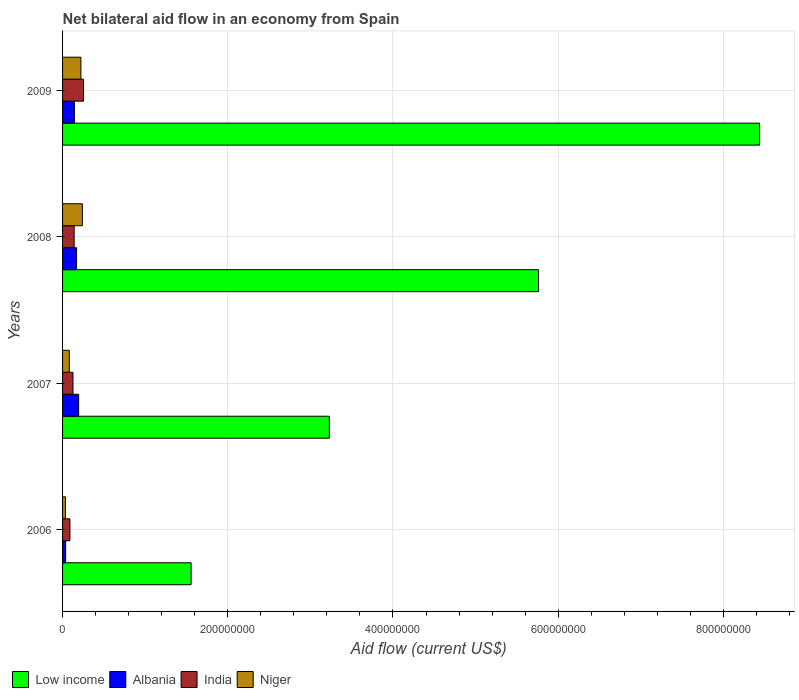How many different coloured bars are there?
Your response must be concise. 4. How many groups of bars are there?
Offer a terse response. 4. Are the number of bars on each tick of the Y-axis equal?
Give a very brief answer. Yes. How many bars are there on the 4th tick from the top?
Provide a succinct answer. 4. How many bars are there on the 4th tick from the bottom?
Offer a very short reply. 4. What is the net bilateral aid flow in Low income in 2009?
Keep it short and to the point. 8.44e+08. Across all years, what is the maximum net bilateral aid flow in Low income?
Keep it short and to the point. 8.44e+08. Across all years, what is the minimum net bilateral aid flow in Low income?
Make the answer very short. 1.56e+08. What is the total net bilateral aid flow in Low income in the graph?
Give a very brief answer. 1.90e+09. What is the difference between the net bilateral aid flow in Niger in 2007 and that in 2008?
Give a very brief answer. -1.58e+07. What is the difference between the net bilateral aid flow in Niger in 2006 and the net bilateral aid flow in Albania in 2007?
Provide a short and direct response. -1.60e+07. What is the average net bilateral aid flow in Low income per year?
Offer a very short reply. 4.75e+08. In the year 2007, what is the difference between the net bilateral aid flow in India and net bilateral aid flow in Niger?
Ensure brevity in your answer.  4.43e+06. In how many years, is the net bilateral aid flow in India greater than 600000000 US$?
Make the answer very short. 0. What is the ratio of the net bilateral aid flow in India in 2008 to that in 2009?
Provide a short and direct response. 0.55. Is the net bilateral aid flow in Low income in 2006 less than that in 2009?
Your response must be concise. Yes. What is the difference between the highest and the second highest net bilateral aid flow in India?
Your answer should be compact. 1.13e+07. What is the difference between the highest and the lowest net bilateral aid flow in Low income?
Provide a succinct answer. 6.88e+08. In how many years, is the net bilateral aid flow in Albania greater than the average net bilateral aid flow in Albania taken over all years?
Provide a succinct answer. 3. Is the sum of the net bilateral aid flow in Low income in 2006 and 2007 greater than the maximum net bilateral aid flow in India across all years?
Your answer should be very brief. Yes. Is it the case that in every year, the sum of the net bilateral aid flow in Low income and net bilateral aid flow in India is greater than the sum of net bilateral aid flow in Niger and net bilateral aid flow in Albania?
Provide a short and direct response. Yes. What does the 1st bar from the top in 2007 represents?
Provide a succinct answer. Niger. What does the 2nd bar from the bottom in 2006 represents?
Provide a short and direct response. Albania. Is it the case that in every year, the sum of the net bilateral aid flow in India and net bilateral aid flow in Niger is greater than the net bilateral aid flow in Low income?
Provide a short and direct response. No. How many bars are there?
Offer a very short reply. 16. How many years are there in the graph?
Your answer should be compact. 4. Are the values on the major ticks of X-axis written in scientific E-notation?
Provide a succinct answer. No. Does the graph contain any zero values?
Offer a very short reply. No. Does the graph contain grids?
Make the answer very short. Yes. Where does the legend appear in the graph?
Keep it short and to the point. Bottom left. How many legend labels are there?
Your answer should be compact. 4. How are the legend labels stacked?
Provide a succinct answer. Horizontal. What is the title of the graph?
Your answer should be compact. Net bilateral aid flow in an economy from Spain. Does "Sierra Leone" appear as one of the legend labels in the graph?
Give a very brief answer. No. What is the label or title of the Y-axis?
Your response must be concise. Years. What is the Aid flow (current US$) of Low income in 2006?
Provide a short and direct response. 1.56e+08. What is the Aid flow (current US$) of Albania in 2006?
Keep it short and to the point. 3.71e+06. What is the Aid flow (current US$) in India in 2006?
Ensure brevity in your answer.  8.91e+06. What is the Aid flow (current US$) of Niger in 2006?
Keep it short and to the point. 3.49e+06. What is the Aid flow (current US$) of Low income in 2007?
Provide a short and direct response. 3.23e+08. What is the Aid flow (current US$) in Albania in 2007?
Provide a short and direct response. 1.95e+07. What is the Aid flow (current US$) of India in 2007?
Provide a succinct answer. 1.26e+07. What is the Aid flow (current US$) of Niger in 2007?
Offer a very short reply. 8.19e+06. What is the Aid flow (current US$) of Low income in 2008?
Keep it short and to the point. 5.76e+08. What is the Aid flow (current US$) in Albania in 2008?
Your answer should be very brief. 1.69e+07. What is the Aid flow (current US$) in India in 2008?
Your answer should be very brief. 1.40e+07. What is the Aid flow (current US$) in Niger in 2008?
Provide a succinct answer. 2.40e+07. What is the Aid flow (current US$) in Low income in 2009?
Give a very brief answer. 8.44e+08. What is the Aid flow (current US$) of Albania in 2009?
Ensure brevity in your answer.  1.43e+07. What is the Aid flow (current US$) in India in 2009?
Keep it short and to the point. 2.53e+07. What is the Aid flow (current US$) of Niger in 2009?
Provide a short and direct response. 2.22e+07. Across all years, what is the maximum Aid flow (current US$) of Low income?
Provide a succinct answer. 8.44e+08. Across all years, what is the maximum Aid flow (current US$) of Albania?
Ensure brevity in your answer.  1.95e+07. Across all years, what is the maximum Aid flow (current US$) in India?
Provide a short and direct response. 2.53e+07. Across all years, what is the maximum Aid flow (current US$) of Niger?
Make the answer very short. 2.40e+07. Across all years, what is the minimum Aid flow (current US$) of Low income?
Provide a short and direct response. 1.56e+08. Across all years, what is the minimum Aid flow (current US$) in Albania?
Your response must be concise. 3.71e+06. Across all years, what is the minimum Aid flow (current US$) in India?
Keep it short and to the point. 8.91e+06. Across all years, what is the minimum Aid flow (current US$) in Niger?
Give a very brief answer. 3.49e+06. What is the total Aid flow (current US$) in Low income in the graph?
Your response must be concise. 1.90e+09. What is the total Aid flow (current US$) of Albania in the graph?
Make the answer very short. 5.44e+07. What is the total Aid flow (current US$) of India in the graph?
Provide a succinct answer. 6.09e+07. What is the total Aid flow (current US$) in Niger in the graph?
Make the answer very short. 5.79e+07. What is the difference between the Aid flow (current US$) in Low income in 2006 and that in 2007?
Provide a succinct answer. -1.67e+08. What is the difference between the Aid flow (current US$) in Albania in 2006 and that in 2007?
Your answer should be compact. -1.58e+07. What is the difference between the Aid flow (current US$) in India in 2006 and that in 2007?
Offer a very short reply. -3.71e+06. What is the difference between the Aid flow (current US$) in Niger in 2006 and that in 2007?
Your answer should be very brief. -4.70e+06. What is the difference between the Aid flow (current US$) of Low income in 2006 and that in 2008?
Your answer should be very brief. -4.21e+08. What is the difference between the Aid flow (current US$) in Albania in 2006 and that in 2008?
Provide a short and direct response. -1.32e+07. What is the difference between the Aid flow (current US$) of India in 2006 and that in 2008?
Offer a very short reply. -5.13e+06. What is the difference between the Aid flow (current US$) in Niger in 2006 and that in 2008?
Offer a terse response. -2.05e+07. What is the difference between the Aid flow (current US$) in Low income in 2006 and that in 2009?
Give a very brief answer. -6.88e+08. What is the difference between the Aid flow (current US$) in Albania in 2006 and that in 2009?
Make the answer very short. -1.06e+07. What is the difference between the Aid flow (current US$) in India in 2006 and that in 2009?
Provide a succinct answer. -1.64e+07. What is the difference between the Aid flow (current US$) of Niger in 2006 and that in 2009?
Your answer should be very brief. -1.87e+07. What is the difference between the Aid flow (current US$) of Low income in 2007 and that in 2008?
Your response must be concise. -2.53e+08. What is the difference between the Aid flow (current US$) of Albania in 2007 and that in 2008?
Provide a short and direct response. 2.54e+06. What is the difference between the Aid flow (current US$) in India in 2007 and that in 2008?
Ensure brevity in your answer.  -1.42e+06. What is the difference between the Aid flow (current US$) of Niger in 2007 and that in 2008?
Provide a succinct answer. -1.58e+07. What is the difference between the Aid flow (current US$) of Low income in 2007 and that in 2009?
Your response must be concise. -5.21e+08. What is the difference between the Aid flow (current US$) in Albania in 2007 and that in 2009?
Your answer should be compact. 5.13e+06. What is the difference between the Aid flow (current US$) in India in 2007 and that in 2009?
Provide a succinct answer. -1.27e+07. What is the difference between the Aid flow (current US$) of Niger in 2007 and that in 2009?
Your response must be concise. -1.40e+07. What is the difference between the Aid flow (current US$) of Low income in 2008 and that in 2009?
Provide a succinct answer. -2.68e+08. What is the difference between the Aid flow (current US$) in Albania in 2008 and that in 2009?
Make the answer very short. 2.59e+06. What is the difference between the Aid flow (current US$) of India in 2008 and that in 2009?
Your response must be concise. -1.13e+07. What is the difference between the Aid flow (current US$) in Niger in 2008 and that in 2009?
Offer a very short reply. 1.78e+06. What is the difference between the Aid flow (current US$) of Low income in 2006 and the Aid flow (current US$) of Albania in 2007?
Keep it short and to the point. 1.36e+08. What is the difference between the Aid flow (current US$) of Low income in 2006 and the Aid flow (current US$) of India in 2007?
Provide a short and direct response. 1.43e+08. What is the difference between the Aid flow (current US$) of Low income in 2006 and the Aid flow (current US$) of Niger in 2007?
Offer a very short reply. 1.47e+08. What is the difference between the Aid flow (current US$) in Albania in 2006 and the Aid flow (current US$) in India in 2007?
Keep it short and to the point. -8.91e+06. What is the difference between the Aid flow (current US$) in Albania in 2006 and the Aid flow (current US$) in Niger in 2007?
Your response must be concise. -4.48e+06. What is the difference between the Aid flow (current US$) of India in 2006 and the Aid flow (current US$) of Niger in 2007?
Make the answer very short. 7.20e+05. What is the difference between the Aid flow (current US$) in Low income in 2006 and the Aid flow (current US$) in Albania in 2008?
Provide a succinct answer. 1.39e+08. What is the difference between the Aid flow (current US$) of Low income in 2006 and the Aid flow (current US$) of India in 2008?
Offer a terse response. 1.42e+08. What is the difference between the Aid flow (current US$) in Low income in 2006 and the Aid flow (current US$) in Niger in 2008?
Keep it short and to the point. 1.32e+08. What is the difference between the Aid flow (current US$) of Albania in 2006 and the Aid flow (current US$) of India in 2008?
Keep it short and to the point. -1.03e+07. What is the difference between the Aid flow (current US$) in Albania in 2006 and the Aid flow (current US$) in Niger in 2008?
Provide a succinct answer. -2.03e+07. What is the difference between the Aid flow (current US$) in India in 2006 and the Aid flow (current US$) in Niger in 2008?
Provide a succinct answer. -1.51e+07. What is the difference between the Aid flow (current US$) of Low income in 2006 and the Aid flow (current US$) of Albania in 2009?
Make the answer very short. 1.41e+08. What is the difference between the Aid flow (current US$) in Low income in 2006 and the Aid flow (current US$) in India in 2009?
Provide a short and direct response. 1.30e+08. What is the difference between the Aid flow (current US$) of Low income in 2006 and the Aid flow (current US$) of Niger in 2009?
Your answer should be compact. 1.33e+08. What is the difference between the Aid flow (current US$) of Albania in 2006 and the Aid flow (current US$) of India in 2009?
Your answer should be very brief. -2.16e+07. What is the difference between the Aid flow (current US$) of Albania in 2006 and the Aid flow (current US$) of Niger in 2009?
Offer a very short reply. -1.85e+07. What is the difference between the Aid flow (current US$) of India in 2006 and the Aid flow (current US$) of Niger in 2009?
Your response must be concise. -1.33e+07. What is the difference between the Aid flow (current US$) of Low income in 2007 and the Aid flow (current US$) of Albania in 2008?
Give a very brief answer. 3.06e+08. What is the difference between the Aid flow (current US$) of Low income in 2007 and the Aid flow (current US$) of India in 2008?
Ensure brevity in your answer.  3.09e+08. What is the difference between the Aid flow (current US$) of Low income in 2007 and the Aid flow (current US$) of Niger in 2008?
Give a very brief answer. 2.99e+08. What is the difference between the Aid flow (current US$) in Albania in 2007 and the Aid flow (current US$) in India in 2008?
Ensure brevity in your answer.  5.43e+06. What is the difference between the Aid flow (current US$) of Albania in 2007 and the Aid flow (current US$) of Niger in 2008?
Give a very brief answer. -4.51e+06. What is the difference between the Aid flow (current US$) of India in 2007 and the Aid flow (current US$) of Niger in 2008?
Give a very brief answer. -1.14e+07. What is the difference between the Aid flow (current US$) in Low income in 2007 and the Aid flow (current US$) in Albania in 2009?
Provide a succinct answer. 3.09e+08. What is the difference between the Aid flow (current US$) of Low income in 2007 and the Aid flow (current US$) of India in 2009?
Your answer should be compact. 2.98e+08. What is the difference between the Aid flow (current US$) of Low income in 2007 and the Aid flow (current US$) of Niger in 2009?
Your response must be concise. 3.01e+08. What is the difference between the Aid flow (current US$) of Albania in 2007 and the Aid flow (current US$) of India in 2009?
Offer a very short reply. -5.87e+06. What is the difference between the Aid flow (current US$) of Albania in 2007 and the Aid flow (current US$) of Niger in 2009?
Give a very brief answer. -2.73e+06. What is the difference between the Aid flow (current US$) in India in 2007 and the Aid flow (current US$) in Niger in 2009?
Keep it short and to the point. -9.58e+06. What is the difference between the Aid flow (current US$) of Low income in 2008 and the Aid flow (current US$) of Albania in 2009?
Ensure brevity in your answer.  5.62e+08. What is the difference between the Aid flow (current US$) of Low income in 2008 and the Aid flow (current US$) of India in 2009?
Keep it short and to the point. 5.51e+08. What is the difference between the Aid flow (current US$) of Low income in 2008 and the Aid flow (current US$) of Niger in 2009?
Provide a short and direct response. 5.54e+08. What is the difference between the Aid flow (current US$) of Albania in 2008 and the Aid flow (current US$) of India in 2009?
Offer a very short reply. -8.41e+06. What is the difference between the Aid flow (current US$) in Albania in 2008 and the Aid flow (current US$) in Niger in 2009?
Your response must be concise. -5.27e+06. What is the difference between the Aid flow (current US$) in India in 2008 and the Aid flow (current US$) in Niger in 2009?
Provide a succinct answer. -8.16e+06. What is the average Aid flow (current US$) of Low income per year?
Your response must be concise. 4.75e+08. What is the average Aid flow (current US$) of Albania per year?
Give a very brief answer. 1.36e+07. What is the average Aid flow (current US$) in India per year?
Ensure brevity in your answer.  1.52e+07. What is the average Aid flow (current US$) of Niger per year?
Your answer should be very brief. 1.45e+07. In the year 2006, what is the difference between the Aid flow (current US$) in Low income and Aid flow (current US$) in Albania?
Offer a very short reply. 1.52e+08. In the year 2006, what is the difference between the Aid flow (current US$) of Low income and Aid flow (current US$) of India?
Keep it short and to the point. 1.47e+08. In the year 2006, what is the difference between the Aid flow (current US$) of Low income and Aid flow (current US$) of Niger?
Ensure brevity in your answer.  1.52e+08. In the year 2006, what is the difference between the Aid flow (current US$) in Albania and Aid flow (current US$) in India?
Keep it short and to the point. -5.20e+06. In the year 2006, what is the difference between the Aid flow (current US$) in India and Aid flow (current US$) in Niger?
Keep it short and to the point. 5.42e+06. In the year 2007, what is the difference between the Aid flow (current US$) in Low income and Aid flow (current US$) in Albania?
Provide a short and direct response. 3.03e+08. In the year 2007, what is the difference between the Aid flow (current US$) in Low income and Aid flow (current US$) in India?
Your answer should be very brief. 3.10e+08. In the year 2007, what is the difference between the Aid flow (current US$) of Low income and Aid flow (current US$) of Niger?
Ensure brevity in your answer.  3.15e+08. In the year 2007, what is the difference between the Aid flow (current US$) of Albania and Aid flow (current US$) of India?
Ensure brevity in your answer.  6.85e+06. In the year 2007, what is the difference between the Aid flow (current US$) of Albania and Aid flow (current US$) of Niger?
Ensure brevity in your answer.  1.13e+07. In the year 2007, what is the difference between the Aid flow (current US$) in India and Aid flow (current US$) in Niger?
Give a very brief answer. 4.43e+06. In the year 2008, what is the difference between the Aid flow (current US$) of Low income and Aid flow (current US$) of Albania?
Your answer should be very brief. 5.59e+08. In the year 2008, what is the difference between the Aid flow (current US$) of Low income and Aid flow (current US$) of India?
Provide a short and direct response. 5.62e+08. In the year 2008, what is the difference between the Aid flow (current US$) in Low income and Aid flow (current US$) in Niger?
Provide a succinct answer. 5.52e+08. In the year 2008, what is the difference between the Aid flow (current US$) of Albania and Aid flow (current US$) of India?
Offer a very short reply. 2.89e+06. In the year 2008, what is the difference between the Aid flow (current US$) of Albania and Aid flow (current US$) of Niger?
Make the answer very short. -7.05e+06. In the year 2008, what is the difference between the Aid flow (current US$) in India and Aid flow (current US$) in Niger?
Ensure brevity in your answer.  -9.94e+06. In the year 2009, what is the difference between the Aid flow (current US$) in Low income and Aid flow (current US$) in Albania?
Your response must be concise. 8.30e+08. In the year 2009, what is the difference between the Aid flow (current US$) in Low income and Aid flow (current US$) in India?
Keep it short and to the point. 8.19e+08. In the year 2009, what is the difference between the Aid flow (current US$) in Low income and Aid flow (current US$) in Niger?
Your answer should be very brief. 8.22e+08. In the year 2009, what is the difference between the Aid flow (current US$) in Albania and Aid flow (current US$) in India?
Your answer should be very brief. -1.10e+07. In the year 2009, what is the difference between the Aid flow (current US$) of Albania and Aid flow (current US$) of Niger?
Keep it short and to the point. -7.86e+06. In the year 2009, what is the difference between the Aid flow (current US$) of India and Aid flow (current US$) of Niger?
Give a very brief answer. 3.14e+06. What is the ratio of the Aid flow (current US$) of Low income in 2006 to that in 2007?
Make the answer very short. 0.48. What is the ratio of the Aid flow (current US$) in Albania in 2006 to that in 2007?
Offer a very short reply. 0.19. What is the ratio of the Aid flow (current US$) of India in 2006 to that in 2007?
Provide a short and direct response. 0.71. What is the ratio of the Aid flow (current US$) in Niger in 2006 to that in 2007?
Make the answer very short. 0.43. What is the ratio of the Aid flow (current US$) in Low income in 2006 to that in 2008?
Give a very brief answer. 0.27. What is the ratio of the Aid flow (current US$) in Albania in 2006 to that in 2008?
Give a very brief answer. 0.22. What is the ratio of the Aid flow (current US$) of India in 2006 to that in 2008?
Your answer should be very brief. 0.63. What is the ratio of the Aid flow (current US$) in Niger in 2006 to that in 2008?
Offer a very short reply. 0.15. What is the ratio of the Aid flow (current US$) of Low income in 2006 to that in 2009?
Provide a succinct answer. 0.18. What is the ratio of the Aid flow (current US$) in Albania in 2006 to that in 2009?
Ensure brevity in your answer.  0.26. What is the ratio of the Aid flow (current US$) of India in 2006 to that in 2009?
Provide a succinct answer. 0.35. What is the ratio of the Aid flow (current US$) in Niger in 2006 to that in 2009?
Provide a short and direct response. 0.16. What is the ratio of the Aid flow (current US$) of Low income in 2007 to that in 2008?
Ensure brevity in your answer.  0.56. What is the ratio of the Aid flow (current US$) of Albania in 2007 to that in 2008?
Provide a succinct answer. 1.15. What is the ratio of the Aid flow (current US$) in India in 2007 to that in 2008?
Your answer should be compact. 0.9. What is the ratio of the Aid flow (current US$) of Niger in 2007 to that in 2008?
Provide a succinct answer. 0.34. What is the ratio of the Aid flow (current US$) of Low income in 2007 to that in 2009?
Give a very brief answer. 0.38. What is the ratio of the Aid flow (current US$) in Albania in 2007 to that in 2009?
Your response must be concise. 1.36. What is the ratio of the Aid flow (current US$) of India in 2007 to that in 2009?
Offer a very short reply. 0.5. What is the ratio of the Aid flow (current US$) in Niger in 2007 to that in 2009?
Offer a terse response. 0.37. What is the ratio of the Aid flow (current US$) in Low income in 2008 to that in 2009?
Provide a succinct answer. 0.68. What is the ratio of the Aid flow (current US$) in Albania in 2008 to that in 2009?
Ensure brevity in your answer.  1.18. What is the ratio of the Aid flow (current US$) in India in 2008 to that in 2009?
Keep it short and to the point. 0.55. What is the ratio of the Aid flow (current US$) in Niger in 2008 to that in 2009?
Your response must be concise. 1.08. What is the difference between the highest and the second highest Aid flow (current US$) of Low income?
Your answer should be compact. 2.68e+08. What is the difference between the highest and the second highest Aid flow (current US$) of Albania?
Give a very brief answer. 2.54e+06. What is the difference between the highest and the second highest Aid flow (current US$) of India?
Your answer should be very brief. 1.13e+07. What is the difference between the highest and the second highest Aid flow (current US$) in Niger?
Provide a succinct answer. 1.78e+06. What is the difference between the highest and the lowest Aid flow (current US$) of Low income?
Provide a succinct answer. 6.88e+08. What is the difference between the highest and the lowest Aid flow (current US$) of Albania?
Offer a terse response. 1.58e+07. What is the difference between the highest and the lowest Aid flow (current US$) of India?
Provide a short and direct response. 1.64e+07. What is the difference between the highest and the lowest Aid flow (current US$) of Niger?
Make the answer very short. 2.05e+07. 